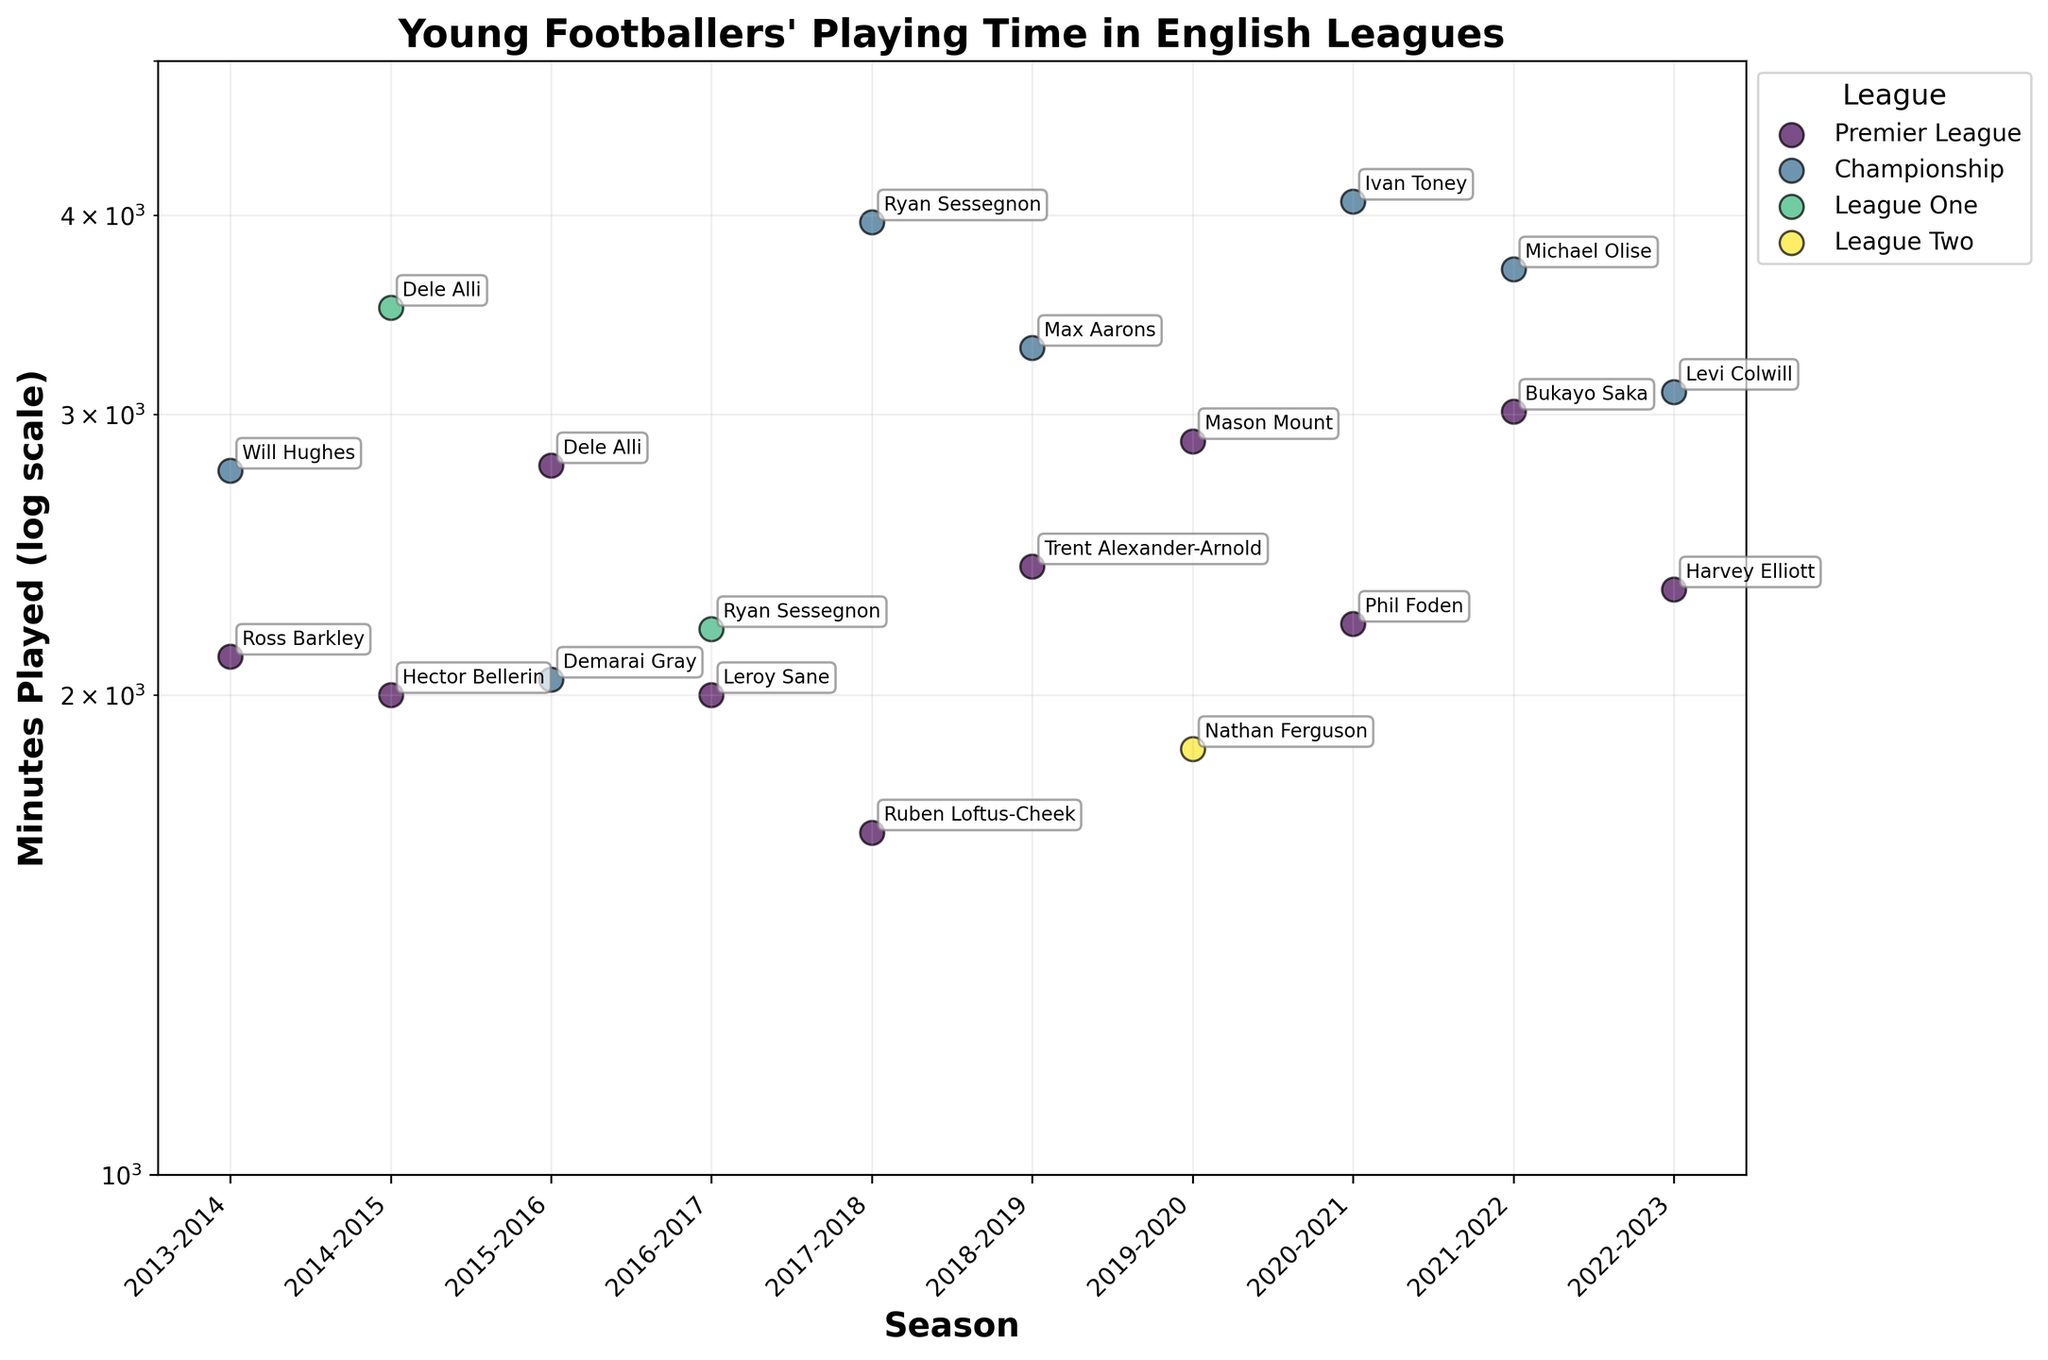How many leagues are represented in the figure? Observe the color legend on the right side of the figure. Each color represents a different league. Count the number of unique colors.
Answer: 5 Which player in the Premier League played the most minutes in the 2021-2022 season? Locate the Premier League data points for the 2021-2022 season. Identify the highest point on the plot, and look for the player's name annotation.
Answer: Bukayo Saka What's the range of minutes played by young footballers in League Two across all seasons? Identify the data points for League Two. Find the minimum and maximum values for "Minutes Played" among these points (log scale).
Answer: 1850-1850 Which season saw the highest minutes played by a young footballer in the Championship? Identify all Championship data points. Look for the highest point on the plot and note its corresponding season.
Answer: 2020-2021 Is there any player who played exactly 2000 minutes in the Premier League? Look for data points labeled "Premier League" and check if any of them have exactly 2000 minutes played. Look for annotations corresponding to these points.
Answer: Yes, Hector Bellerin Compare the minutes played by Ryan Sessegnon in the seasons he is present. Identify all the data points for Ryan Sessegnon and compare their y-axis position (minutes played). Sessegnon has two data points in 2016-2017 and 2017-2018. Note and compare the respective values.
Answer: 2200 and 3960 What is the average minutes played by young footballers in the Premier League for the seasons shown in the plot? Identify all Premier League data points. Sum their "Minutes Played" and divide by the number of data points. Verify if the average calculation is aligned with the log scale.
Answer: (2114 + 2000 + 2788 + 2000 + 1640 + 2409 + 2887 + 2217 + 3012 + 2330) / 10 = 23399 / 10 = ~2340 How does Trent Alexander-Arnold's minutes played in 2018-2019 compare to Hector Bellerin's in 2014-2015? Locate the data points for both players in their respective seasons. Compare their "Minutes Played" values, focusing on the vertical position in the log scale.
Answer: Alexander-Arnold: 2409 > Bellerin: 2000 What trend do you observe for players with minutes played in the log scale beyond 3500 in Championship? Identify points in the Championship with "Minutes Played" above 3500. Observe and note any trend in seasons and player annotations.
Answer: Mostly concentrated around 2017-2018 and 2020-2021 seasons with players like Ryan Sessegnon and Ivan Toney getting high minutes Which league has the widest range of minutes played by young footballers? Identify data points for each league, calculate the range (max value - min value) of "Minutes Played" for each league. Compare these ranges.
Answer: Championship 